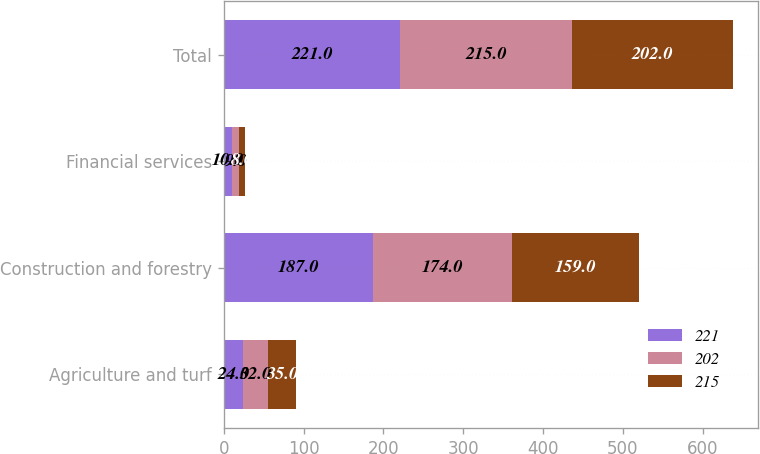Convert chart. <chart><loc_0><loc_0><loc_500><loc_500><stacked_bar_chart><ecel><fcel>Agriculture and turf<fcel>Construction and forestry<fcel>Financial services<fcel>Total<nl><fcel>221<fcel>24<fcel>187<fcel>10<fcel>221<nl><fcel>202<fcel>32<fcel>174<fcel>9<fcel>215<nl><fcel>215<fcel>35<fcel>159<fcel>8<fcel>202<nl></chart> 